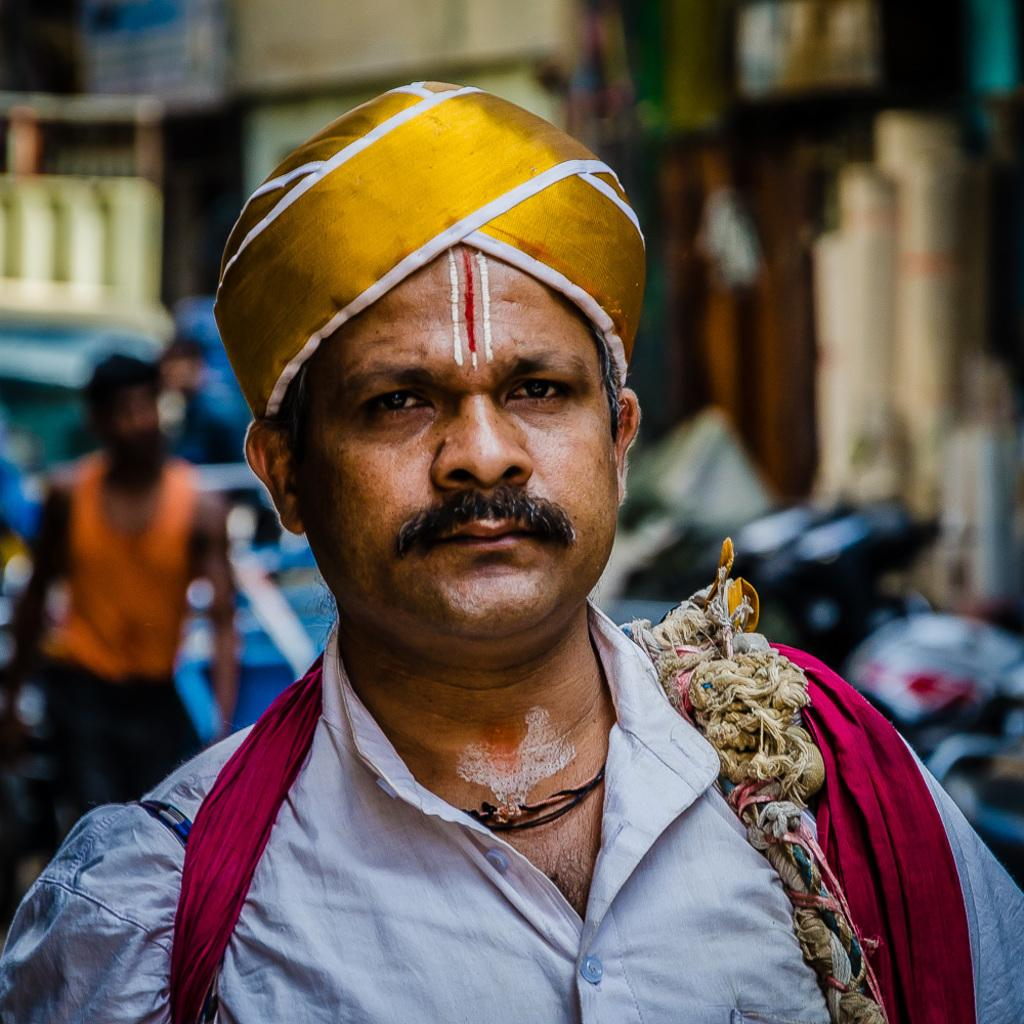Who is present in the image? There is a man in the image. Can you describe the background of the image? The background of the image is blurry. Are there any other people visible in the image? Yes, there is a person visible in the background of the image. What type of disease is the man suffering from in the image? There is no indication of any disease in the image; it only shows a man and a blurry background. What kind of pipe can be seen in the image? There is no pipe present in the image. 